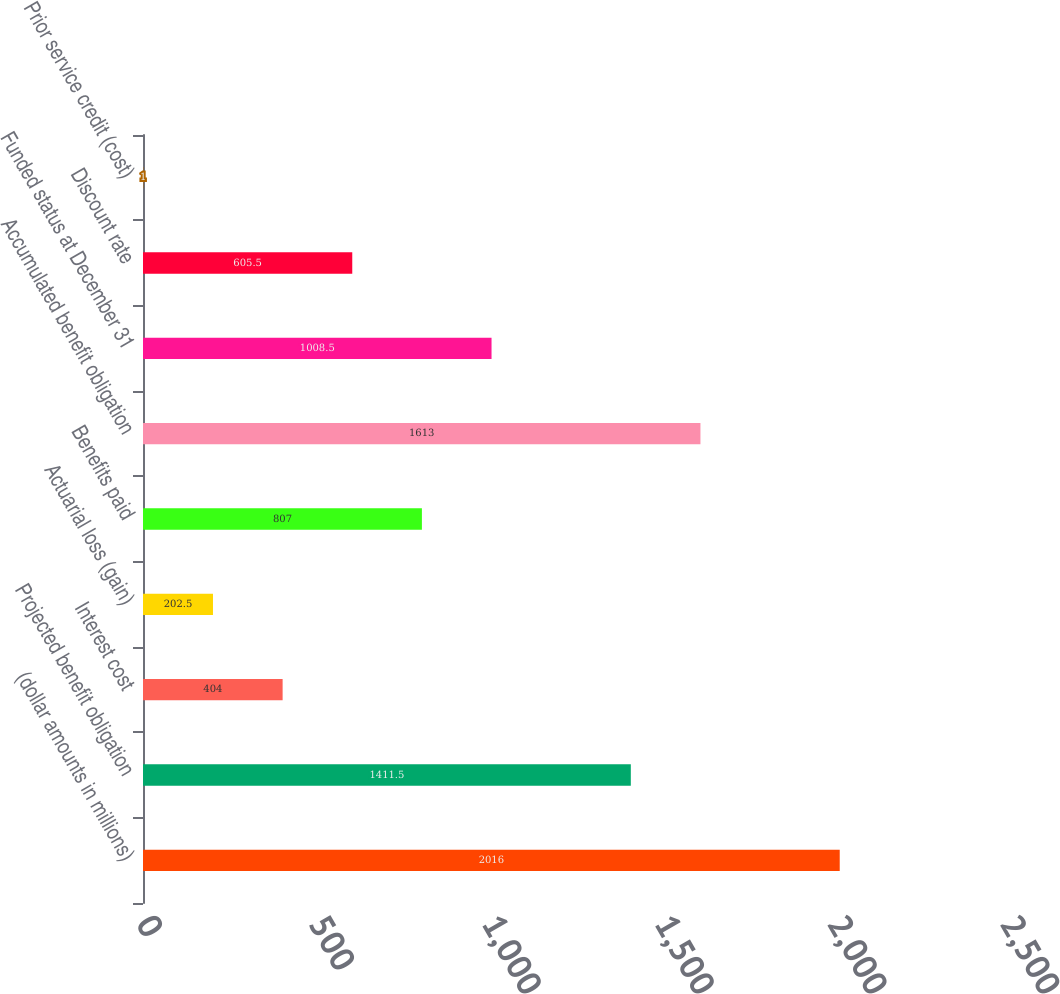<chart> <loc_0><loc_0><loc_500><loc_500><bar_chart><fcel>(dollar amounts in millions)<fcel>Projected benefit obligation<fcel>Interest cost<fcel>Actuarial loss (gain)<fcel>Benefits paid<fcel>Accumulated benefit obligation<fcel>Funded status at December 31<fcel>Discount rate<fcel>Prior service credit (cost)<nl><fcel>2016<fcel>1411.5<fcel>404<fcel>202.5<fcel>807<fcel>1613<fcel>1008.5<fcel>605.5<fcel>1<nl></chart> 